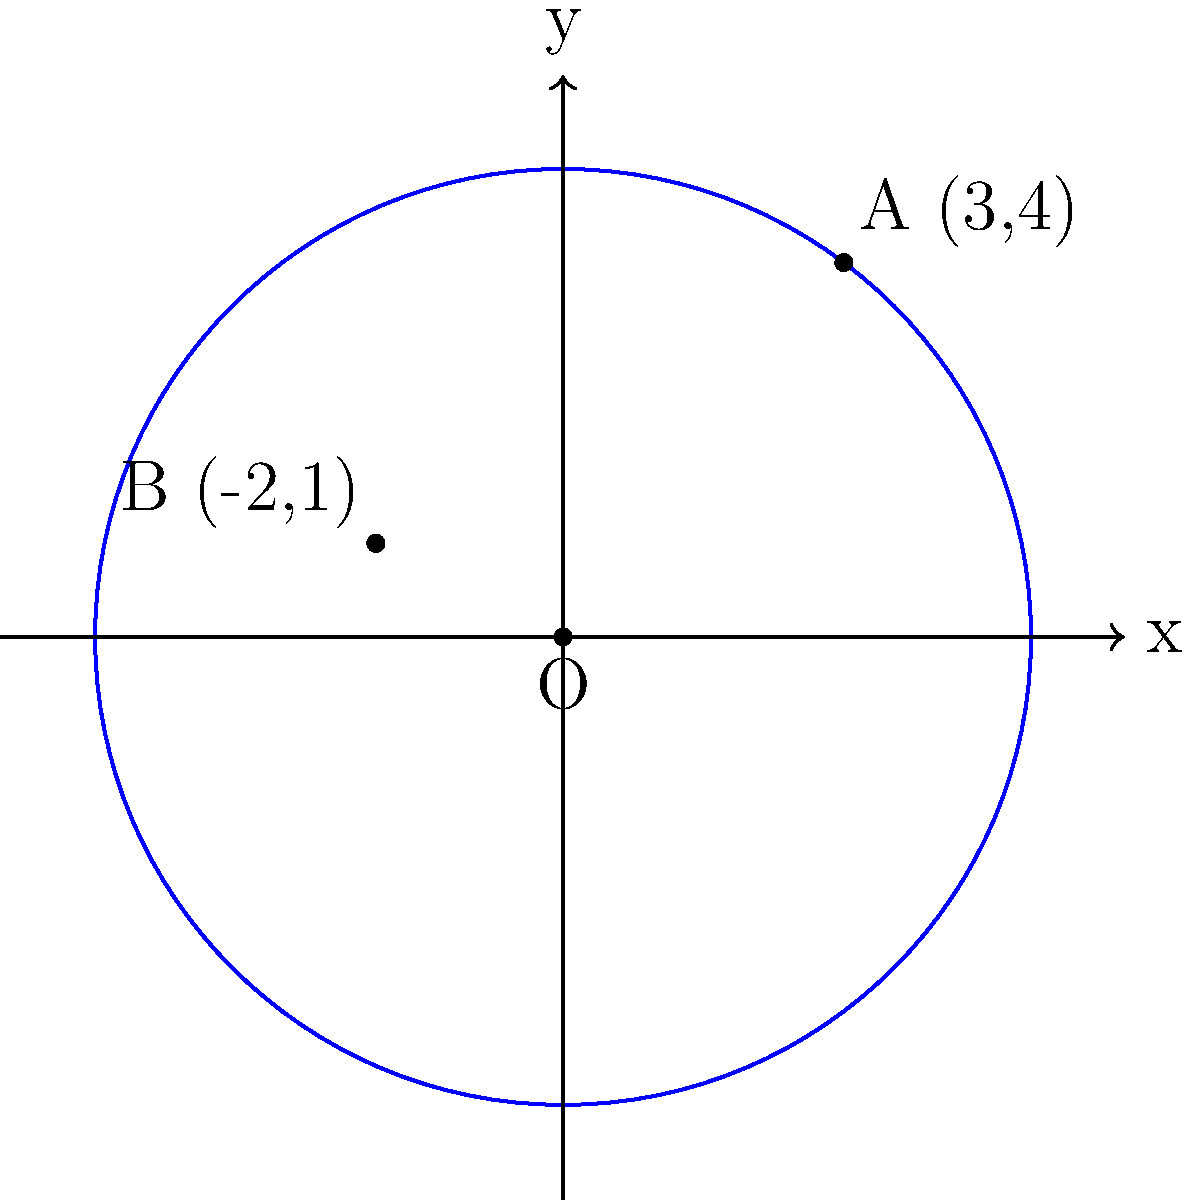In the context of expanding comfort zones for recovering individuals, consider a circular comfort zone centered at the origin O(0,0). Two points on the circumference of this circle represent milestones in the individual's recovery journey: A(3,4) and B(-2,1). Determine the equation of this circle, which represents the current extent of the individual's comfort zone. To find the equation of the circle, we'll follow these steps:

1) The general equation of a circle is $(x-h)^2 + (y-k)^2 = r^2$, where (h,k) is the center and r is the radius.

2) We're given that the center is at the origin (0,0), so h=0 and k=0. Our equation simplifies to:

   $x^2 + y^2 = r^2$

3) To find r, we can use either point A or B. Let's use A(3,4):

   $r^2 = 3^2 + 4^2 = 9 + 16 = 25$

4) Therefore, $r = 5$

5) We can verify this using point B(-2,1):

   $(-2)^2 + 1^2 = 4 + 1 = 5$, which is indeed the radius.

6) Substituting r=5 into our equation:

   $x^2 + y^2 = 5^2 = 25$

This equation represents the circle of the individual's current comfort zone.
Answer: $x^2 + y^2 = 25$ 